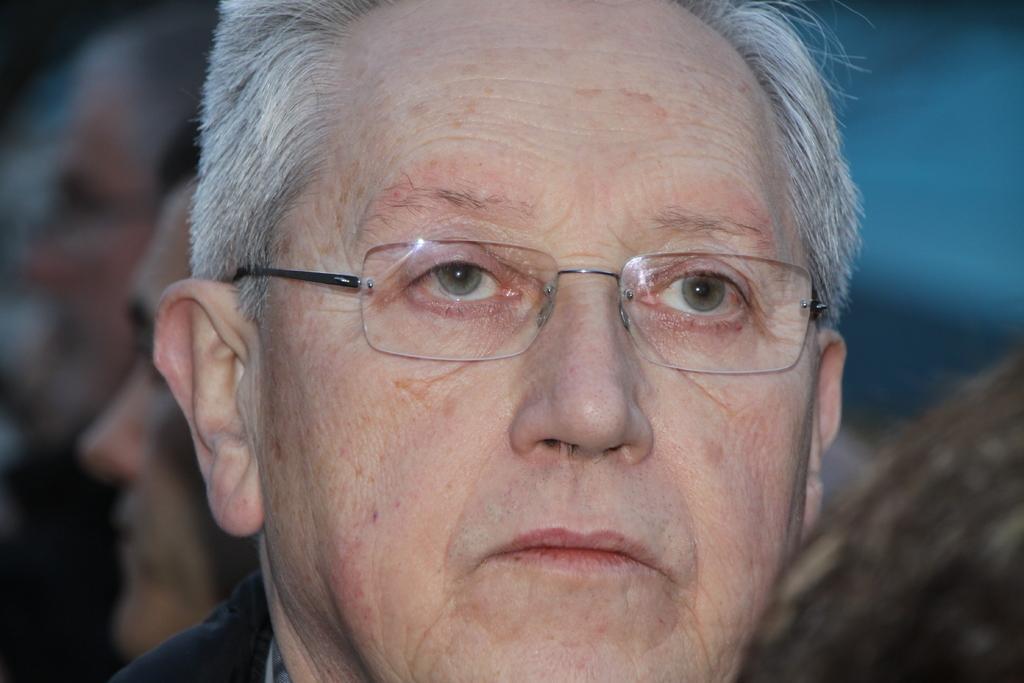Describe this image in one or two sentences. In this image we can see a man with a specs. In the background there are few people and it is blurry. 